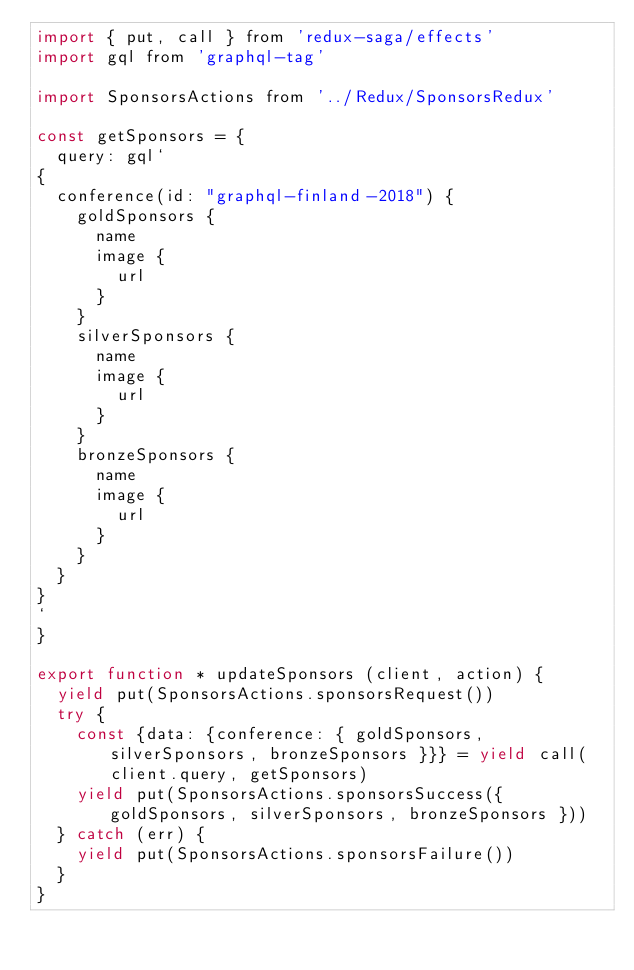<code> <loc_0><loc_0><loc_500><loc_500><_JavaScript_>import { put, call } from 'redux-saga/effects'
import gql from 'graphql-tag'

import SponsorsActions from '../Redux/SponsorsRedux'

const getSponsors = {
  query: gql`
{
  conference(id: "graphql-finland-2018") {
    goldSponsors {
      name
      image {
        url
      }
    }
    silverSponsors {
      name
      image {
        url
      }
    }
    bronzeSponsors {
      name
      image {
        url
      }
    }
  }
}
`
}

export function * updateSponsors (client, action) {
  yield put(SponsorsActions.sponsorsRequest())
  try {
    const {data: {conference: { goldSponsors, silverSponsors, bronzeSponsors }}} = yield call(client.query, getSponsors)
    yield put(SponsorsActions.sponsorsSuccess({ goldSponsors, silverSponsors, bronzeSponsors }))
  } catch (err) {
    yield put(SponsorsActions.sponsorsFailure())
  }
}
</code> 